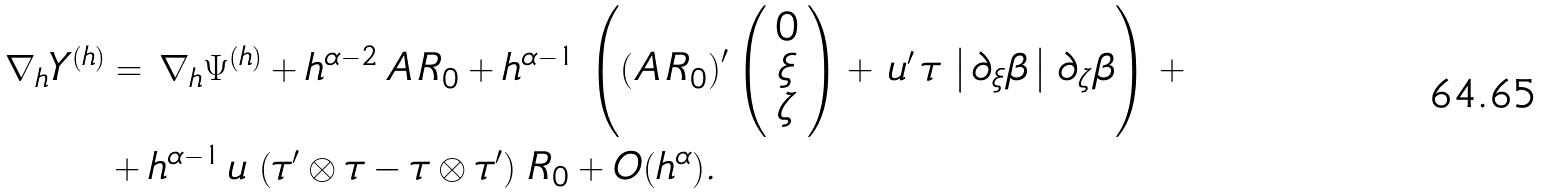Convert formula to latex. <formula><loc_0><loc_0><loc_500><loc_500>\nabla _ { h } Y ^ { ( h ) } & = \, \nabla _ { h } \Psi ^ { ( h ) } + h ^ { \alpha - 2 } \, A \, R _ { 0 } + h ^ { \alpha - 1 } \, \left ( \left ( A \, R _ { 0 } \right ) ^ { \prime } \left ( \begin{array} { c } 0 \\ \xi \\ \zeta \end{array} \right ) + \, u ^ { \prime } \, \tau \, \left | \, \partial _ { \xi } \beta \, \right | \, \partial _ { \zeta } \beta \right ) \, + \\ & + h ^ { \alpha - 1 } \, u \, \left ( \tau ^ { \prime } \otimes \tau - \tau \otimes \tau ^ { \prime } \right ) \, R _ { 0 } + O ( h ^ { \alpha } ) .</formula> 